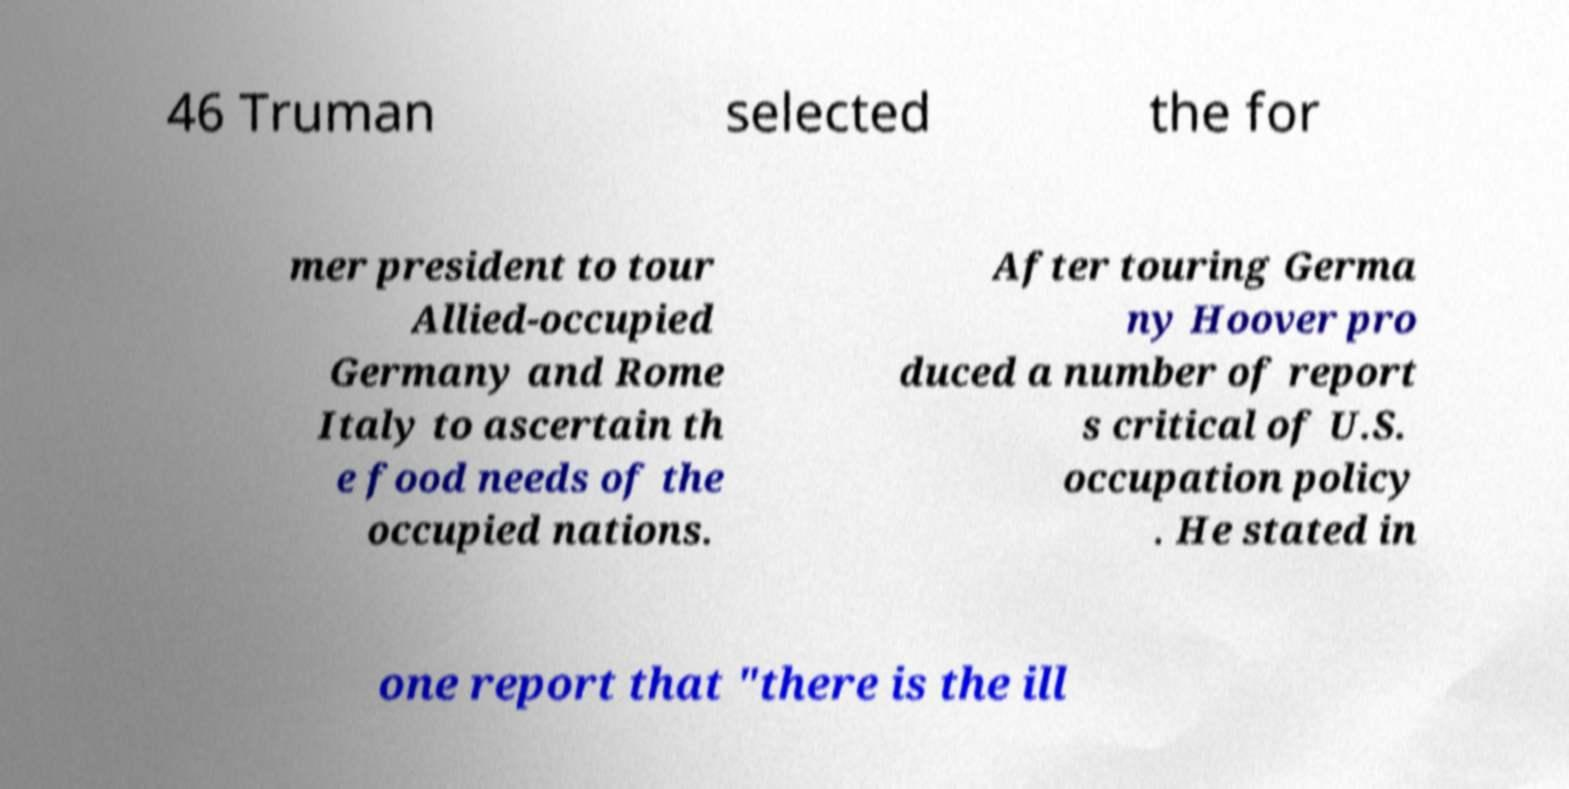What messages or text are displayed in this image? I need them in a readable, typed format. 46 Truman selected the for mer president to tour Allied-occupied Germany and Rome Italy to ascertain th e food needs of the occupied nations. After touring Germa ny Hoover pro duced a number of report s critical of U.S. occupation policy . He stated in one report that "there is the ill 